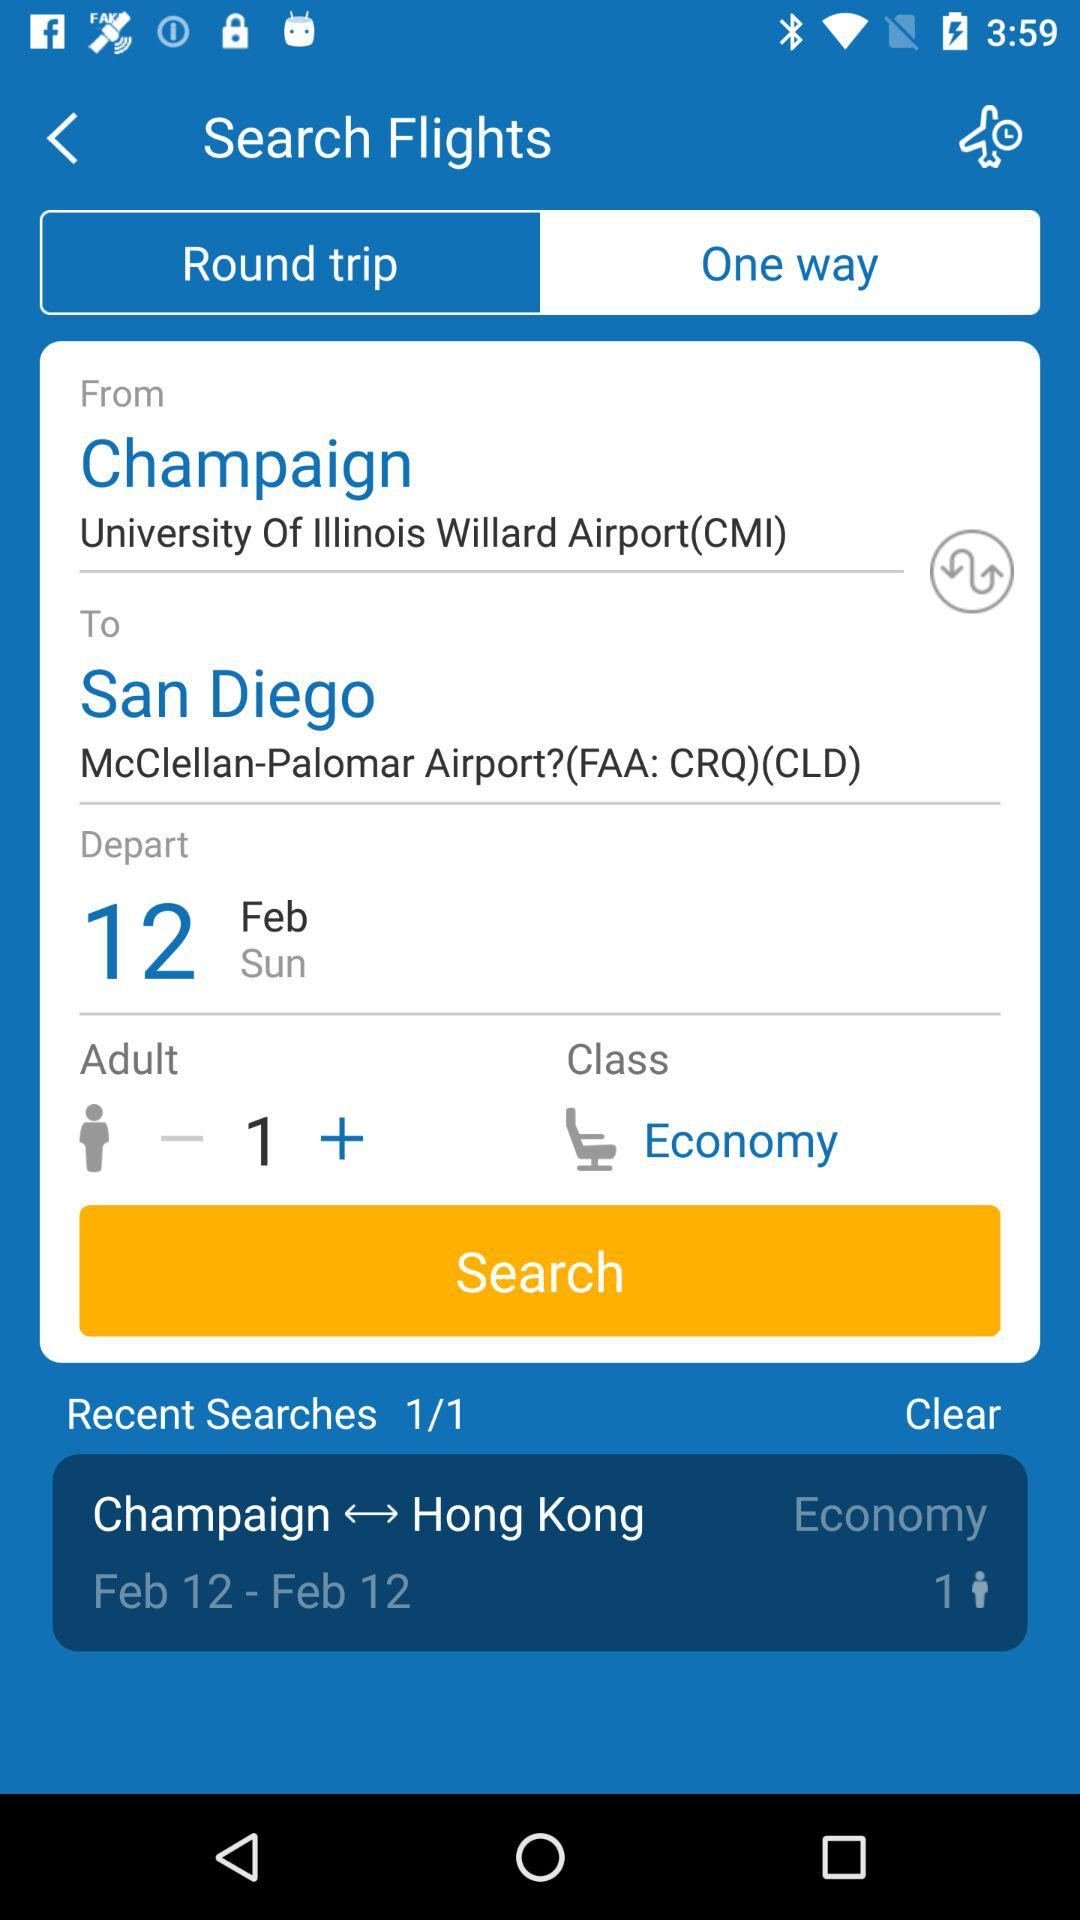How many adults are being booked on this flight?
Answer the question using a single word or phrase. 1 